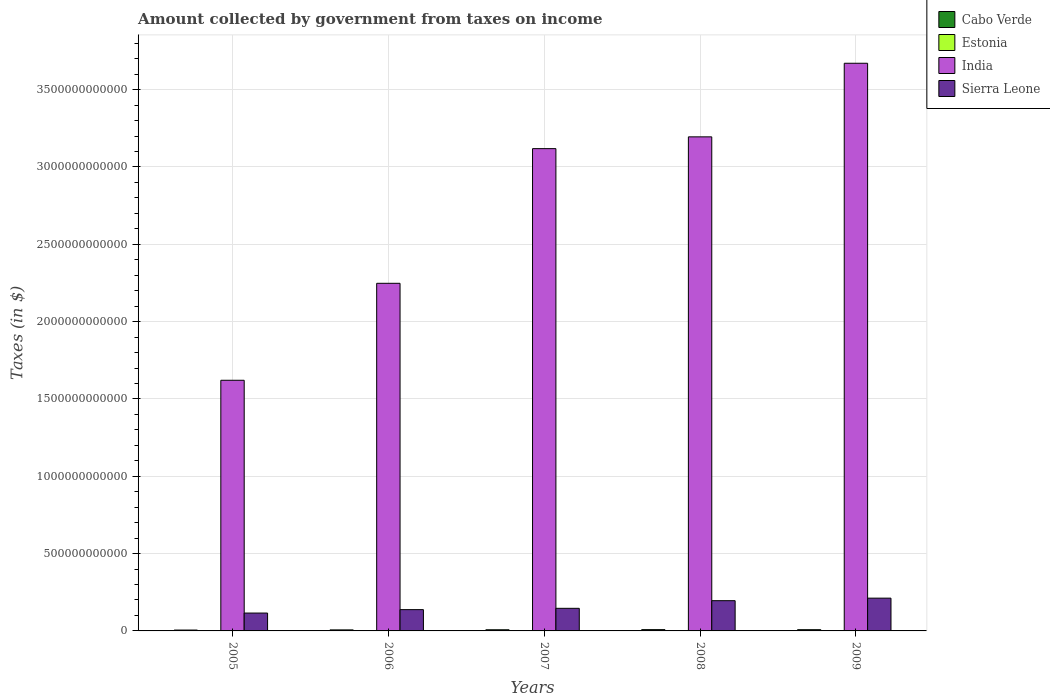How many different coloured bars are there?
Give a very brief answer. 4. Are the number of bars on each tick of the X-axis equal?
Offer a terse response. Yes. How many bars are there on the 2nd tick from the left?
Make the answer very short. 4. What is the label of the 5th group of bars from the left?
Make the answer very short. 2009. What is the amount collected by government from taxes on income in Sierra Leone in 2006?
Keep it short and to the point. 1.38e+11. Across all years, what is the maximum amount collected by government from taxes on income in Cabo Verde?
Give a very brief answer. 8.38e+09. Across all years, what is the minimum amount collected by government from taxes on income in India?
Offer a very short reply. 1.62e+12. In which year was the amount collected by government from taxes on income in Sierra Leone minimum?
Offer a terse response. 2005. What is the total amount collected by government from taxes on income in Sierra Leone in the graph?
Give a very brief answer. 8.07e+11. What is the difference between the amount collected by government from taxes on income in Estonia in 2005 and that in 2006?
Your answer should be compact. -7.05e+07. What is the difference between the amount collected by government from taxes on income in India in 2007 and the amount collected by government from taxes on income in Cabo Verde in 2005?
Your answer should be very brief. 3.11e+12. What is the average amount collected by government from taxes on income in India per year?
Offer a terse response. 2.77e+12. In the year 2008, what is the difference between the amount collected by government from taxes on income in Estonia and amount collected by government from taxes on income in India?
Your response must be concise. -3.19e+12. What is the ratio of the amount collected by government from taxes on income in Sierra Leone in 2006 to that in 2007?
Provide a short and direct response. 0.94. Is the amount collected by government from taxes on income in Sierra Leone in 2005 less than that in 2006?
Provide a short and direct response. Yes. Is the difference between the amount collected by government from taxes on income in Estonia in 2005 and 2006 greater than the difference between the amount collected by government from taxes on income in India in 2005 and 2006?
Ensure brevity in your answer.  Yes. What is the difference between the highest and the second highest amount collected by government from taxes on income in Sierra Leone?
Offer a terse response. 1.64e+1. What is the difference between the highest and the lowest amount collected by government from taxes on income in India?
Your answer should be very brief. 2.05e+12. What does the 4th bar from the left in 2009 represents?
Keep it short and to the point. Sierra Leone. What does the 4th bar from the right in 2006 represents?
Give a very brief answer. Cabo Verde. Is it the case that in every year, the sum of the amount collected by government from taxes on income in Sierra Leone and amount collected by government from taxes on income in Cabo Verde is greater than the amount collected by government from taxes on income in Estonia?
Give a very brief answer. Yes. How many years are there in the graph?
Keep it short and to the point. 5. What is the difference between two consecutive major ticks on the Y-axis?
Make the answer very short. 5.00e+11. Are the values on the major ticks of Y-axis written in scientific E-notation?
Provide a short and direct response. No. Does the graph contain any zero values?
Offer a very short reply. No. Where does the legend appear in the graph?
Provide a succinct answer. Top right. How many legend labels are there?
Your response must be concise. 4. How are the legend labels stacked?
Provide a short and direct response. Vertical. What is the title of the graph?
Offer a terse response. Amount collected by government from taxes on income. What is the label or title of the X-axis?
Provide a succinct answer. Years. What is the label or title of the Y-axis?
Your response must be concise. Taxes (in $). What is the Taxes (in $) of Cabo Verde in 2005?
Make the answer very short. 5.60e+09. What is the Taxes (in $) in Estonia in 2005?
Your answer should be compact. 3.75e+08. What is the Taxes (in $) in India in 2005?
Keep it short and to the point. 1.62e+12. What is the Taxes (in $) of Sierra Leone in 2005?
Provide a short and direct response. 1.16e+11. What is the Taxes (in $) of Cabo Verde in 2006?
Provide a succinct answer. 6.65e+09. What is the Taxes (in $) in Estonia in 2006?
Offer a terse response. 4.46e+08. What is the Taxes (in $) in India in 2006?
Give a very brief answer. 2.25e+12. What is the Taxes (in $) of Sierra Leone in 2006?
Your answer should be compact. 1.38e+11. What is the Taxes (in $) of Cabo Verde in 2007?
Provide a succinct answer. 7.46e+09. What is the Taxes (in $) in Estonia in 2007?
Offer a terse response. 5.67e+08. What is the Taxes (in $) in India in 2007?
Your response must be concise. 3.12e+12. What is the Taxes (in $) in Sierra Leone in 2007?
Offer a terse response. 1.46e+11. What is the Taxes (in $) of Cabo Verde in 2008?
Your answer should be very brief. 8.38e+09. What is the Taxes (in $) of Estonia in 2008?
Offer a very short reply. 5.43e+08. What is the Taxes (in $) of India in 2008?
Keep it short and to the point. 3.19e+12. What is the Taxes (in $) of Sierra Leone in 2008?
Provide a succinct answer. 1.96e+11. What is the Taxes (in $) in Cabo Verde in 2009?
Provide a succinct answer. 7.91e+09. What is the Taxes (in $) of Estonia in 2009?
Ensure brevity in your answer.  4.11e+08. What is the Taxes (in $) of India in 2009?
Offer a terse response. 3.67e+12. What is the Taxes (in $) of Sierra Leone in 2009?
Offer a very short reply. 2.12e+11. Across all years, what is the maximum Taxes (in $) in Cabo Verde?
Make the answer very short. 8.38e+09. Across all years, what is the maximum Taxes (in $) in Estonia?
Provide a succinct answer. 5.67e+08. Across all years, what is the maximum Taxes (in $) in India?
Ensure brevity in your answer.  3.67e+12. Across all years, what is the maximum Taxes (in $) in Sierra Leone?
Give a very brief answer. 2.12e+11. Across all years, what is the minimum Taxes (in $) of Cabo Verde?
Provide a succinct answer. 5.60e+09. Across all years, what is the minimum Taxes (in $) in Estonia?
Your answer should be compact. 3.75e+08. Across all years, what is the minimum Taxes (in $) of India?
Make the answer very short. 1.62e+12. Across all years, what is the minimum Taxes (in $) of Sierra Leone?
Provide a succinct answer. 1.16e+11. What is the total Taxes (in $) in Cabo Verde in the graph?
Provide a succinct answer. 3.60e+1. What is the total Taxes (in $) in Estonia in the graph?
Give a very brief answer. 2.34e+09. What is the total Taxes (in $) in India in the graph?
Your response must be concise. 1.39e+13. What is the total Taxes (in $) of Sierra Leone in the graph?
Your answer should be very brief. 8.07e+11. What is the difference between the Taxes (in $) of Cabo Verde in 2005 and that in 2006?
Ensure brevity in your answer.  -1.05e+09. What is the difference between the Taxes (in $) of Estonia in 2005 and that in 2006?
Make the answer very short. -7.05e+07. What is the difference between the Taxes (in $) of India in 2005 and that in 2006?
Keep it short and to the point. -6.27e+11. What is the difference between the Taxes (in $) in Sierra Leone in 2005 and that in 2006?
Your answer should be very brief. -2.22e+1. What is the difference between the Taxes (in $) in Cabo Verde in 2005 and that in 2007?
Keep it short and to the point. -1.86e+09. What is the difference between the Taxes (in $) of Estonia in 2005 and that in 2007?
Offer a terse response. -1.92e+08. What is the difference between the Taxes (in $) in India in 2005 and that in 2007?
Your response must be concise. -1.50e+12. What is the difference between the Taxes (in $) in Sierra Leone in 2005 and that in 2007?
Provide a succinct answer. -3.07e+1. What is the difference between the Taxes (in $) in Cabo Verde in 2005 and that in 2008?
Keep it short and to the point. -2.78e+09. What is the difference between the Taxes (in $) in Estonia in 2005 and that in 2008?
Offer a terse response. -1.68e+08. What is the difference between the Taxes (in $) in India in 2005 and that in 2008?
Provide a succinct answer. -1.57e+12. What is the difference between the Taxes (in $) in Sierra Leone in 2005 and that in 2008?
Offer a very short reply. -8.00e+1. What is the difference between the Taxes (in $) of Cabo Verde in 2005 and that in 2009?
Your answer should be very brief. -2.31e+09. What is the difference between the Taxes (in $) of Estonia in 2005 and that in 2009?
Your answer should be very brief. -3.58e+07. What is the difference between the Taxes (in $) of India in 2005 and that in 2009?
Make the answer very short. -2.05e+12. What is the difference between the Taxes (in $) of Sierra Leone in 2005 and that in 2009?
Your answer should be compact. -9.64e+1. What is the difference between the Taxes (in $) of Cabo Verde in 2006 and that in 2007?
Provide a short and direct response. -8.07e+08. What is the difference between the Taxes (in $) of Estonia in 2006 and that in 2007?
Your answer should be compact. -1.21e+08. What is the difference between the Taxes (in $) in India in 2006 and that in 2007?
Make the answer very short. -8.71e+11. What is the difference between the Taxes (in $) in Sierra Leone in 2006 and that in 2007?
Keep it short and to the point. -8.50e+09. What is the difference between the Taxes (in $) of Cabo Verde in 2006 and that in 2008?
Make the answer very short. -1.73e+09. What is the difference between the Taxes (in $) in Estonia in 2006 and that in 2008?
Provide a short and direct response. -9.74e+07. What is the difference between the Taxes (in $) in India in 2006 and that in 2008?
Your answer should be very brief. -9.47e+11. What is the difference between the Taxes (in $) in Sierra Leone in 2006 and that in 2008?
Keep it short and to the point. -5.79e+1. What is the difference between the Taxes (in $) of Cabo Verde in 2006 and that in 2009?
Offer a terse response. -1.26e+09. What is the difference between the Taxes (in $) in Estonia in 2006 and that in 2009?
Your answer should be very brief. 3.47e+07. What is the difference between the Taxes (in $) of India in 2006 and that in 2009?
Your answer should be very brief. -1.42e+12. What is the difference between the Taxes (in $) of Sierra Leone in 2006 and that in 2009?
Offer a terse response. -7.42e+1. What is the difference between the Taxes (in $) of Cabo Verde in 2007 and that in 2008?
Make the answer very short. -9.25e+08. What is the difference between the Taxes (in $) in Estonia in 2007 and that in 2008?
Give a very brief answer. 2.40e+07. What is the difference between the Taxes (in $) in India in 2007 and that in 2008?
Ensure brevity in your answer.  -7.62e+1. What is the difference between the Taxes (in $) of Sierra Leone in 2007 and that in 2008?
Your answer should be very brief. -4.94e+1. What is the difference between the Taxes (in $) of Cabo Verde in 2007 and that in 2009?
Offer a very short reply. -4.55e+08. What is the difference between the Taxes (in $) in Estonia in 2007 and that in 2009?
Your answer should be very brief. 1.56e+08. What is the difference between the Taxes (in $) in India in 2007 and that in 2009?
Keep it short and to the point. -5.52e+11. What is the difference between the Taxes (in $) of Sierra Leone in 2007 and that in 2009?
Your answer should be compact. -6.57e+1. What is the difference between the Taxes (in $) in Cabo Verde in 2008 and that in 2009?
Offer a very short reply. 4.70e+08. What is the difference between the Taxes (in $) of Estonia in 2008 and that in 2009?
Ensure brevity in your answer.  1.32e+08. What is the difference between the Taxes (in $) of India in 2008 and that in 2009?
Give a very brief answer. -4.76e+11. What is the difference between the Taxes (in $) of Sierra Leone in 2008 and that in 2009?
Offer a very short reply. -1.64e+1. What is the difference between the Taxes (in $) of Cabo Verde in 2005 and the Taxes (in $) of Estonia in 2006?
Offer a very short reply. 5.15e+09. What is the difference between the Taxes (in $) of Cabo Verde in 2005 and the Taxes (in $) of India in 2006?
Ensure brevity in your answer.  -2.24e+12. What is the difference between the Taxes (in $) of Cabo Verde in 2005 and the Taxes (in $) of Sierra Leone in 2006?
Offer a terse response. -1.32e+11. What is the difference between the Taxes (in $) of Estonia in 2005 and the Taxes (in $) of India in 2006?
Make the answer very short. -2.25e+12. What is the difference between the Taxes (in $) of Estonia in 2005 and the Taxes (in $) of Sierra Leone in 2006?
Provide a succinct answer. -1.37e+11. What is the difference between the Taxes (in $) in India in 2005 and the Taxes (in $) in Sierra Leone in 2006?
Your answer should be compact. 1.48e+12. What is the difference between the Taxes (in $) in Cabo Verde in 2005 and the Taxes (in $) in Estonia in 2007?
Give a very brief answer. 5.03e+09. What is the difference between the Taxes (in $) of Cabo Verde in 2005 and the Taxes (in $) of India in 2007?
Make the answer very short. -3.11e+12. What is the difference between the Taxes (in $) of Cabo Verde in 2005 and the Taxes (in $) of Sierra Leone in 2007?
Ensure brevity in your answer.  -1.41e+11. What is the difference between the Taxes (in $) of Estonia in 2005 and the Taxes (in $) of India in 2007?
Provide a short and direct response. -3.12e+12. What is the difference between the Taxes (in $) of Estonia in 2005 and the Taxes (in $) of Sierra Leone in 2007?
Make the answer very short. -1.46e+11. What is the difference between the Taxes (in $) of India in 2005 and the Taxes (in $) of Sierra Leone in 2007?
Give a very brief answer. 1.47e+12. What is the difference between the Taxes (in $) of Cabo Verde in 2005 and the Taxes (in $) of Estonia in 2008?
Offer a very short reply. 5.05e+09. What is the difference between the Taxes (in $) in Cabo Verde in 2005 and the Taxes (in $) in India in 2008?
Your answer should be very brief. -3.19e+12. What is the difference between the Taxes (in $) in Cabo Verde in 2005 and the Taxes (in $) in Sierra Leone in 2008?
Ensure brevity in your answer.  -1.90e+11. What is the difference between the Taxes (in $) of Estonia in 2005 and the Taxes (in $) of India in 2008?
Your answer should be compact. -3.19e+12. What is the difference between the Taxes (in $) in Estonia in 2005 and the Taxes (in $) in Sierra Leone in 2008?
Offer a very short reply. -1.95e+11. What is the difference between the Taxes (in $) in India in 2005 and the Taxes (in $) in Sierra Leone in 2008?
Offer a very short reply. 1.43e+12. What is the difference between the Taxes (in $) in Cabo Verde in 2005 and the Taxes (in $) in Estonia in 2009?
Offer a terse response. 5.19e+09. What is the difference between the Taxes (in $) in Cabo Verde in 2005 and the Taxes (in $) in India in 2009?
Ensure brevity in your answer.  -3.67e+12. What is the difference between the Taxes (in $) of Cabo Verde in 2005 and the Taxes (in $) of Sierra Leone in 2009?
Offer a very short reply. -2.06e+11. What is the difference between the Taxes (in $) of Estonia in 2005 and the Taxes (in $) of India in 2009?
Keep it short and to the point. -3.67e+12. What is the difference between the Taxes (in $) in Estonia in 2005 and the Taxes (in $) in Sierra Leone in 2009?
Make the answer very short. -2.12e+11. What is the difference between the Taxes (in $) of India in 2005 and the Taxes (in $) of Sierra Leone in 2009?
Provide a short and direct response. 1.41e+12. What is the difference between the Taxes (in $) of Cabo Verde in 2006 and the Taxes (in $) of Estonia in 2007?
Make the answer very short. 6.08e+09. What is the difference between the Taxes (in $) of Cabo Verde in 2006 and the Taxes (in $) of India in 2007?
Keep it short and to the point. -3.11e+12. What is the difference between the Taxes (in $) of Cabo Verde in 2006 and the Taxes (in $) of Sierra Leone in 2007?
Offer a terse response. -1.40e+11. What is the difference between the Taxes (in $) in Estonia in 2006 and the Taxes (in $) in India in 2007?
Your response must be concise. -3.12e+12. What is the difference between the Taxes (in $) of Estonia in 2006 and the Taxes (in $) of Sierra Leone in 2007?
Give a very brief answer. -1.46e+11. What is the difference between the Taxes (in $) in India in 2006 and the Taxes (in $) in Sierra Leone in 2007?
Your answer should be very brief. 2.10e+12. What is the difference between the Taxes (in $) in Cabo Verde in 2006 and the Taxes (in $) in Estonia in 2008?
Ensure brevity in your answer.  6.11e+09. What is the difference between the Taxes (in $) in Cabo Verde in 2006 and the Taxes (in $) in India in 2008?
Your response must be concise. -3.19e+12. What is the difference between the Taxes (in $) in Cabo Verde in 2006 and the Taxes (in $) in Sierra Leone in 2008?
Your answer should be compact. -1.89e+11. What is the difference between the Taxes (in $) of Estonia in 2006 and the Taxes (in $) of India in 2008?
Make the answer very short. -3.19e+12. What is the difference between the Taxes (in $) of Estonia in 2006 and the Taxes (in $) of Sierra Leone in 2008?
Provide a short and direct response. -1.95e+11. What is the difference between the Taxes (in $) in India in 2006 and the Taxes (in $) in Sierra Leone in 2008?
Give a very brief answer. 2.05e+12. What is the difference between the Taxes (in $) in Cabo Verde in 2006 and the Taxes (in $) in Estonia in 2009?
Your response must be concise. 6.24e+09. What is the difference between the Taxes (in $) in Cabo Verde in 2006 and the Taxes (in $) in India in 2009?
Your response must be concise. -3.66e+12. What is the difference between the Taxes (in $) in Cabo Verde in 2006 and the Taxes (in $) in Sierra Leone in 2009?
Provide a succinct answer. -2.05e+11. What is the difference between the Taxes (in $) of Estonia in 2006 and the Taxes (in $) of India in 2009?
Provide a succinct answer. -3.67e+12. What is the difference between the Taxes (in $) of Estonia in 2006 and the Taxes (in $) of Sierra Leone in 2009?
Your answer should be very brief. -2.11e+11. What is the difference between the Taxes (in $) of India in 2006 and the Taxes (in $) of Sierra Leone in 2009?
Your answer should be compact. 2.04e+12. What is the difference between the Taxes (in $) in Cabo Verde in 2007 and the Taxes (in $) in Estonia in 2008?
Make the answer very short. 6.91e+09. What is the difference between the Taxes (in $) of Cabo Verde in 2007 and the Taxes (in $) of India in 2008?
Your answer should be compact. -3.19e+12. What is the difference between the Taxes (in $) of Cabo Verde in 2007 and the Taxes (in $) of Sierra Leone in 2008?
Offer a very short reply. -1.88e+11. What is the difference between the Taxes (in $) of Estonia in 2007 and the Taxes (in $) of India in 2008?
Provide a succinct answer. -3.19e+12. What is the difference between the Taxes (in $) of Estonia in 2007 and the Taxes (in $) of Sierra Leone in 2008?
Your response must be concise. -1.95e+11. What is the difference between the Taxes (in $) of India in 2007 and the Taxes (in $) of Sierra Leone in 2008?
Your answer should be compact. 2.92e+12. What is the difference between the Taxes (in $) in Cabo Verde in 2007 and the Taxes (in $) in Estonia in 2009?
Your answer should be very brief. 7.04e+09. What is the difference between the Taxes (in $) of Cabo Verde in 2007 and the Taxes (in $) of India in 2009?
Keep it short and to the point. -3.66e+12. What is the difference between the Taxes (in $) of Cabo Verde in 2007 and the Taxes (in $) of Sierra Leone in 2009?
Your answer should be very brief. -2.04e+11. What is the difference between the Taxes (in $) of Estonia in 2007 and the Taxes (in $) of India in 2009?
Make the answer very short. -3.67e+12. What is the difference between the Taxes (in $) in Estonia in 2007 and the Taxes (in $) in Sierra Leone in 2009?
Your answer should be compact. -2.11e+11. What is the difference between the Taxes (in $) in India in 2007 and the Taxes (in $) in Sierra Leone in 2009?
Ensure brevity in your answer.  2.91e+12. What is the difference between the Taxes (in $) of Cabo Verde in 2008 and the Taxes (in $) of Estonia in 2009?
Keep it short and to the point. 7.97e+09. What is the difference between the Taxes (in $) in Cabo Verde in 2008 and the Taxes (in $) in India in 2009?
Offer a terse response. -3.66e+12. What is the difference between the Taxes (in $) in Cabo Verde in 2008 and the Taxes (in $) in Sierra Leone in 2009?
Offer a very short reply. -2.04e+11. What is the difference between the Taxes (in $) of Estonia in 2008 and the Taxes (in $) of India in 2009?
Offer a terse response. -3.67e+12. What is the difference between the Taxes (in $) of Estonia in 2008 and the Taxes (in $) of Sierra Leone in 2009?
Offer a very short reply. -2.11e+11. What is the difference between the Taxes (in $) in India in 2008 and the Taxes (in $) in Sierra Leone in 2009?
Provide a short and direct response. 2.98e+12. What is the average Taxes (in $) of Cabo Verde per year?
Provide a succinct answer. 7.20e+09. What is the average Taxes (in $) in Estonia per year?
Offer a very short reply. 4.68e+08. What is the average Taxes (in $) of India per year?
Offer a terse response. 2.77e+12. What is the average Taxes (in $) of Sierra Leone per year?
Ensure brevity in your answer.  1.61e+11. In the year 2005, what is the difference between the Taxes (in $) of Cabo Verde and Taxes (in $) of Estonia?
Offer a terse response. 5.22e+09. In the year 2005, what is the difference between the Taxes (in $) in Cabo Verde and Taxes (in $) in India?
Your response must be concise. -1.62e+12. In the year 2005, what is the difference between the Taxes (in $) in Cabo Verde and Taxes (in $) in Sierra Leone?
Your answer should be compact. -1.10e+11. In the year 2005, what is the difference between the Taxes (in $) of Estonia and Taxes (in $) of India?
Provide a succinct answer. -1.62e+12. In the year 2005, what is the difference between the Taxes (in $) in Estonia and Taxes (in $) in Sierra Leone?
Ensure brevity in your answer.  -1.15e+11. In the year 2005, what is the difference between the Taxes (in $) of India and Taxes (in $) of Sierra Leone?
Offer a very short reply. 1.51e+12. In the year 2006, what is the difference between the Taxes (in $) of Cabo Verde and Taxes (in $) of Estonia?
Make the answer very short. 6.20e+09. In the year 2006, what is the difference between the Taxes (in $) of Cabo Verde and Taxes (in $) of India?
Provide a short and direct response. -2.24e+12. In the year 2006, what is the difference between the Taxes (in $) in Cabo Verde and Taxes (in $) in Sierra Leone?
Keep it short and to the point. -1.31e+11. In the year 2006, what is the difference between the Taxes (in $) of Estonia and Taxes (in $) of India?
Your response must be concise. -2.25e+12. In the year 2006, what is the difference between the Taxes (in $) of Estonia and Taxes (in $) of Sierra Leone?
Keep it short and to the point. -1.37e+11. In the year 2006, what is the difference between the Taxes (in $) in India and Taxes (in $) in Sierra Leone?
Provide a short and direct response. 2.11e+12. In the year 2007, what is the difference between the Taxes (in $) of Cabo Verde and Taxes (in $) of Estonia?
Make the answer very short. 6.89e+09. In the year 2007, what is the difference between the Taxes (in $) in Cabo Verde and Taxes (in $) in India?
Give a very brief answer. -3.11e+12. In the year 2007, what is the difference between the Taxes (in $) of Cabo Verde and Taxes (in $) of Sierra Leone?
Ensure brevity in your answer.  -1.39e+11. In the year 2007, what is the difference between the Taxes (in $) of Estonia and Taxes (in $) of India?
Offer a very short reply. -3.12e+12. In the year 2007, what is the difference between the Taxes (in $) of Estonia and Taxes (in $) of Sierra Leone?
Ensure brevity in your answer.  -1.46e+11. In the year 2007, what is the difference between the Taxes (in $) in India and Taxes (in $) in Sierra Leone?
Give a very brief answer. 2.97e+12. In the year 2008, what is the difference between the Taxes (in $) of Cabo Verde and Taxes (in $) of Estonia?
Give a very brief answer. 7.84e+09. In the year 2008, what is the difference between the Taxes (in $) in Cabo Verde and Taxes (in $) in India?
Ensure brevity in your answer.  -3.19e+12. In the year 2008, what is the difference between the Taxes (in $) of Cabo Verde and Taxes (in $) of Sierra Leone?
Offer a very short reply. -1.87e+11. In the year 2008, what is the difference between the Taxes (in $) in Estonia and Taxes (in $) in India?
Give a very brief answer. -3.19e+12. In the year 2008, what is the difference between the Taxes (in $) in Estonia and Taxes (in $) in Sierra Leone?
Your response must be concise. -1.95e+11. In the year 2008, what is the difference between the Taxes (in $) in India and Taxes (in $) in Sierra Leone?
Give a very brief answer. 3.00e+12. In the year 2009, what is the difference between the Taxes (in $) of Cabo Verde and Taxes (in $) of Estonia?
Provide a short and direct response. 7.50e+09. In the year 2009, what is the difference between the Taxes (in $) in Cabo Verde and Taxes (in $) in India?
Ensure brevity in your answer.  -3.66e+12. In the year 2009, what is the difference between the Taxes (in $) of Cabo Verde and Taxes (in $) of Sierra Leone?
Make the answer very short. -2.04e+11. In the year 2009, what is the difference between the Taxes (in $) in Estonia and Taxes (in $) in India?
Your answer should be compact. -3.67e+12. In the year 2009, what is the difference between the Taxes (in $) in Estonia and Taxes (in $) in Sierra Leone?
Your answer should be compact. -2.11e+11. In the year 2009, what is the difference between the Taxes (in $) in India and Taxes (in $) in Sierra Leone?
Make the answer very short. 3.46e+12. What is the ratio of the Taxes (in $) of Cabo Verde in 2005 to that in 2006?
Give a very brief answer. 0.84. What is the ratio of the Taxes (in $) in Estonia in 2005 to that in 2006?
Ensure brevity in your answer.  0.84. What is the ratio of the Taxes (in $) in India in 2005 to that in 2006?
Provide a short and direct response. 0.72. What is the ratio of the Taxes (in $) of Sierra Leone in 2005 to that in 2006?
Your response must be concise. 0.84. What is the ratio of the Taxes (in $) in Cabo Verde in 2005 to that in 2007?
Offer a very short reply. 0.75. What is the ratio of the Taxes (in $) of Estonia in 2005 to that in 2007?
Ensure brevity in your answer.  0.66. What is the ratio of the Taxes (in $) in India in 2005 to that in 2007?
Your answer should be very brief. 0.52. What is the ratio of the Taxes (in $) in Sierra Leone in 2005 to that in 2007?
Make the answer very short. 0.79. What is the ratio of the Taxes (in $) in Cabo Verde in 2005 to that in 2008?
Provide a succinct answer. 0.67. What is the ratio of the Taxes (in $) in Estonia in 2005 to that in 2008?
Provide a succinct answer. 0.69. What is the ratio of the Taxes (in $) in India in 2005 to that in 2008?
Your answer should be compact. 0.51. What is the ratio of the Taxes (in $) of Sierra Leone in 2005 to that in 2008?
Ensure brevity in your answer.  0.59. What is the ratio of the Taxes (in $) in Cabo Verde in 2005 to that in 2009?
Your response must be concise. 0.71. What is the ratio of the Taxes (in $) in Estonia in 2005 to that in 2009?
Provide a succinct answer. 0.91. What is the ratio of the Taxes (in $) of India in 2005 to that in 2009?
Your answer should be very brief. 0.44. What is the ratio of the Taxes (in $) of Sierra Leone in 2005 to that in 2009?
Offer a terse response. 0.55. What is the ratio of the Taxes (in $) in Cabo Verde in 2006 to that in 2007?
Offer a terse response. 0.89. What is the ratio of the Taxes (in $) of Estonia in 2006 to that in 2007?
Give a very brief answer. 0.79. What is the ratio of the Taxes (in $) of India in 2006 to that in 2007?
Offer a very short reply. 0.72. What is the ratio of the Taxes (in $) in Sierra Leone in 2006 to that in 2007?
Give a very brief answer. 0.94. What is the ratio of the Taxes (in $) of Cabo Verde in 2006 to that in 2008?
Provide a succinct answer. 0.79. What is the ratio of the Taxes (in $) in Estonia in 2006 to that in 2008?
Ensure brevity in your answer.  0.82. What is the ratio of the Taxes (in $) of India in 2006 to that in 2008?
Ensure brevity in your answer.  0.7. What is the ratio of the Taxes (in $) in Sierra Leone in 2006 to that in 2008?
Offer a terse response. 0.7. What is the ratio of the Taxes (in $) of Cabo Verde in 2006 to that in 2009?
Your answer should be compact. 0.84. What is the ratio of the Taxes (in $) in Estonia in 2006 to that in 2009?
Offer a terse response. 1.08. What is the ratio of the Taxes (in $) in India in 2006 to that in 2009?
Offer a very short reply. 0.61. What is the ratio of the Taxes (in $) in Sierra Leone in 2006 to that in 2009?
Your response must be concise. 0.65. What is the ratio of the Taxes (in $) of Cabo Verde in 2007 to that in 2008?
Offer a very short reply. 0.89. What is the ratio of the Taxes (in $) in Estonia in 2007 to that in 2008?
Keep it short and to the point. 1.04. What is the ratio of the Taxes (in $) in India in 2007 to that in 2008?
Your answer should be very brief. 0.98. What is the ratio of the Taxes (in $) in Sierra Leone in 2007 to that in 2008?
Provide a short and direct response. 0.75. What is the ratio of the Taxes (in $) in Cabo Verde in 2007 to that in 2009?
Keep it short and to the point. 0.94. What is the ratio of the Taxes (in $) of Estonia in 2007 to that in 2009?
Ensure brevity in your answer.  1.38. What is the ratio of the Taxes (in $) of India in 2007 to that in 2009?
Your answer should be compact. 0.85. What is the ratio of the Taxes (in $) in Sierra Leone in 2007 to that in 2009?
Your response must be concise. 0.69. What is the ratio of the Taxes (in $) in Cabo Verde in 2008 to that in 2009?
Provide a succinct answer. 1.06. What is the ratio of the Taxes (in $) in Estonia in 2008 to that in 2009?
Give a very brief answer. 1.32. What is the ratio of the Taxes (in $) of India in 2008 to that in 2009?
Offer a very short reply. 0.87. What is the ratio of the Taxes (in $) of Sierra Leone in 2008 to that in 2009?
Offer a terse response. 0.92. What is the difference between the highest and the second highest Taxes (in $) in Cabo Verde?
Your answer should be very brief. 4.70e+08. What is the difference between the highest and the second highest Taxes (in $) of Estonia?
Your answer should be compact. 2.40e+07. What is the difference between the highest and the second highest Taxes (in $) in India?
Your answer should be compact. 4.76e+11. What is the difference between the highest and the second highest Taxes (in $) in Sierra Leone?
Offer a very short reply. 1.64e+1. What is the difference between the highest and the lowest Taxes (in $) in Cabo Verde?
Ensure brevity in your answer.  2.78e+09. What is the difference between the highest and the lowest Taxes (in $) in Estonia?
Your answer should be compact. 1.92e+08. What is the difference between the highest and the lowest Taxes (in $) of India?
Provide a short and direct response. 2.05e+12. What is the difference between the highest and the lowest Taxes (in $) of Sierra Leone?
Your answer should be very brief. 9.64e+1. 